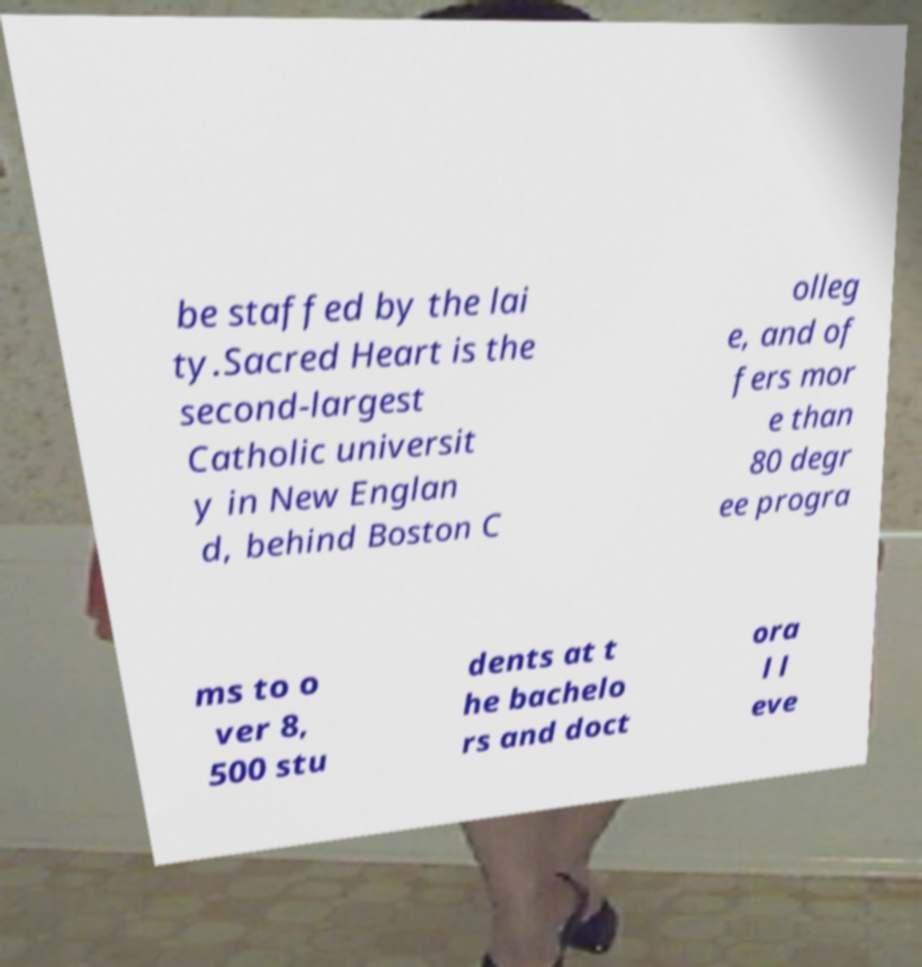Can you read and provide the text displayed in the image?This photo seems to have some interesting text. Can you extract and type it out for me? be staffed by the lai ty.Sacred Heart is the second-largest Catholic universit y in New Englan d, behind Boston C olleg e, and of fers mor e than 80 degr ee progra ms to o ver 8, 500 stu dents at t he bachelo rs and doct ora l l eve 